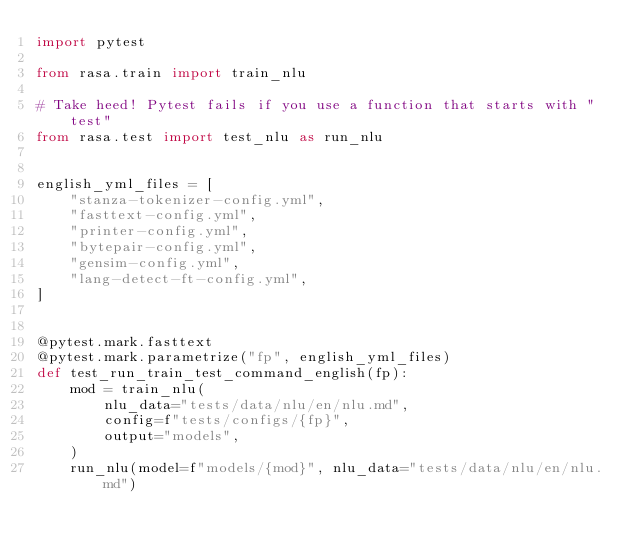<code> <loc_0><loc_0><loc_500><loc_500><_Python_>import pytest

from rasa.train import train_nlu

# Take heed! Pytest fails if you use a function that starts with "test"
from rasa.test import test_nlu as run_nlu


english_yml_files = [
    "stanza-tokenizer-config.yml",
    "fasttext-config.yml",
    "printer-config.yml",
    "bytepair-config.yml",
    "gensim-config.yml",
    "lang-detect-ft-config.yml",
]


@pytest.mark.fasttext
@pytest.mark.parametrize("fp", english_yml_files)
def test_run_train_test_command_english(fp):
    mod = train_nlu(
        nlu_data="tests/data/nlu/en/nlu.md",
        config=f"tests/configs/{fp}",
        output="models",
    )
    run_nlu(model=f"models/{mod}", nlu_data="tests/data/nlu/en/nlu.md")
</code> 